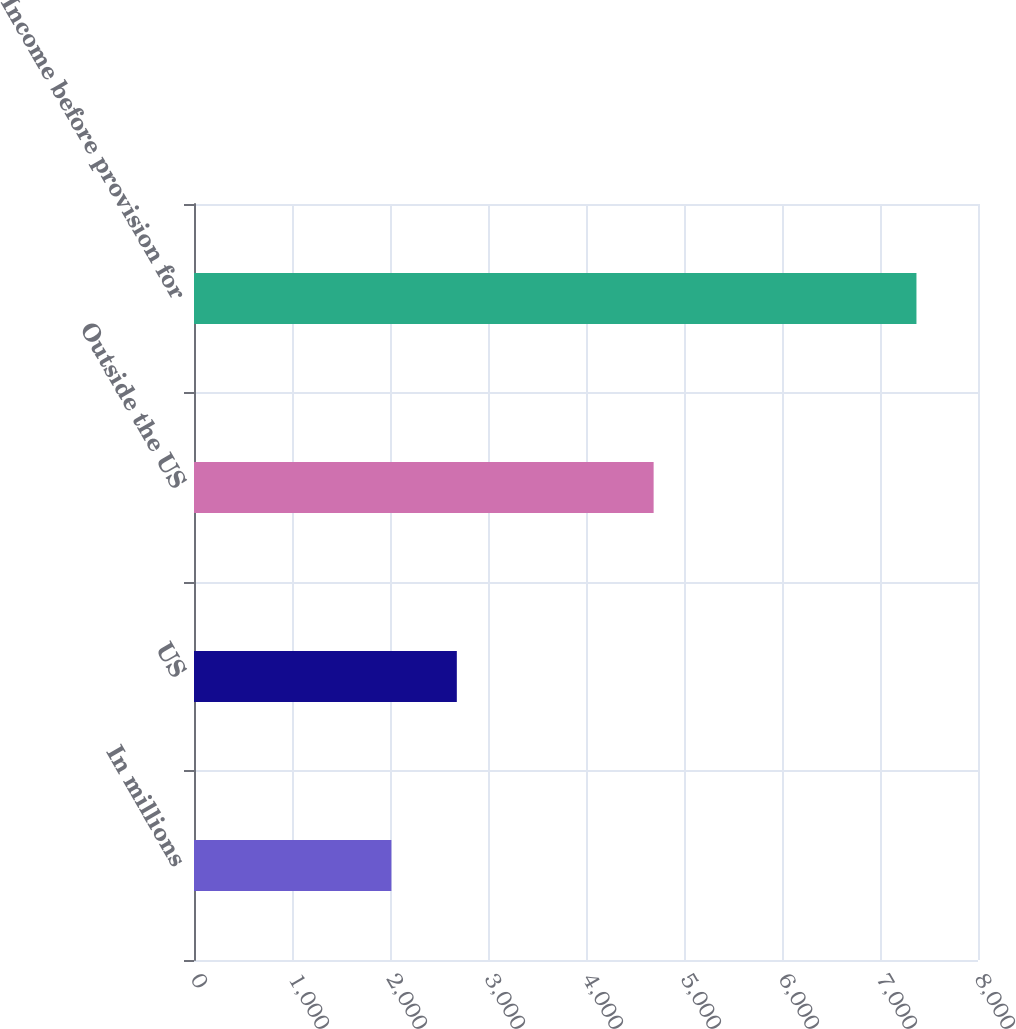<chart> <loc_0><loc_0><loc_500><loc_500><bar_chart><fcel>In millions<fcel>US<fcel>Outside the US<fcel>Income before provision for<nl><fcel>2014<fcel>2681.9<fcel>4690.1<fcel>7372<nl></chart> 